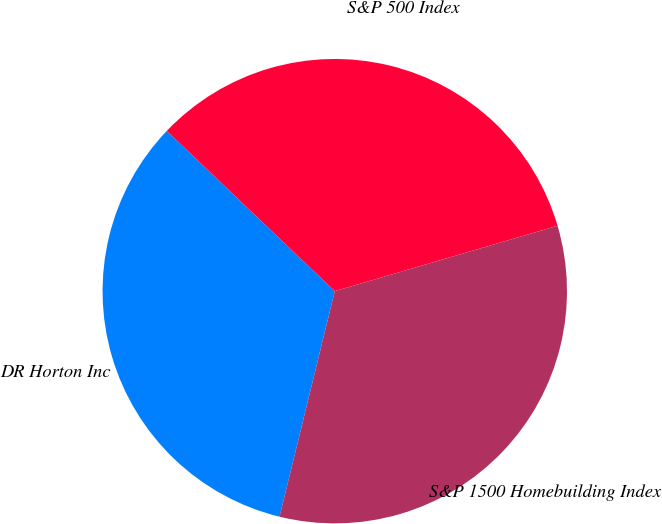Convert chart to OTSL. <chart><loc_0><loc_0><loc_500><loc_500><pie_chart><fcel>DR Horton Inc<fcel>S&P 500 Index<fcel>S&P 1500 Homebuilding Index<nl><fcel>33.3%<fcel>33.33%<fcel>33.37%<nl></chart> 